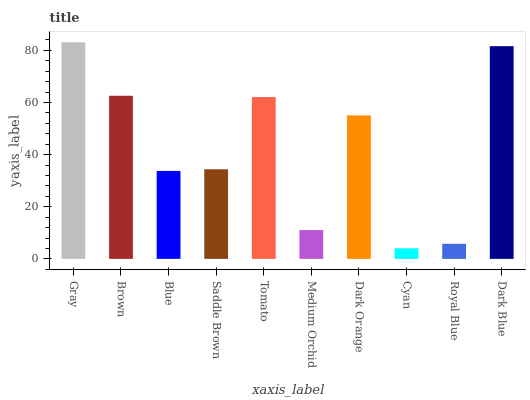Is Cyan the minimum?
Answer yes or no. Yes. Is Gray the maximum?
Answer yes or no. Yes. Is Brown the minimum?
Answer yes or no. No. Is Brown the maximum?
Answer yes or no. No. Is Gray greater than Brown?
Answer yes or no. Yes. Is Brown less than Gray?
Answer yes or no. Yes. Is Brown greater than Gray?
Answer yes or no. No. Is Gray less than Brown?
Answer yes or no. No. Is Dark Orange the high median?
Answer yes or no. Yes. Is Saddle Brown the low median?
Answer yes or no. Yes. Is Dark Blue the high median?
Answer yes or no. No. Is Dark Blue the low median?
Answer yes or no. No. 